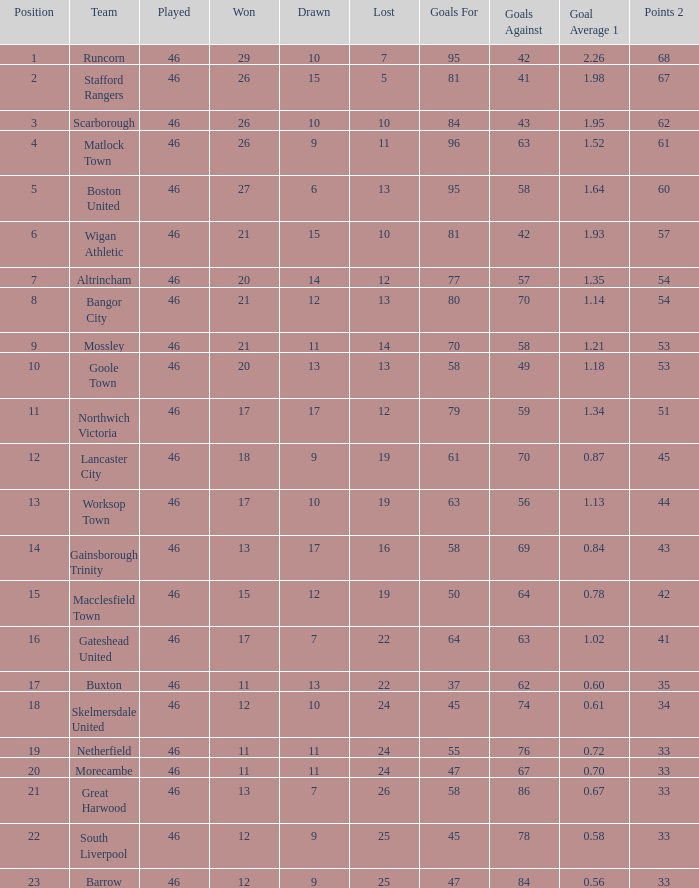List all losses with average goals of 1.21. 14.0. 